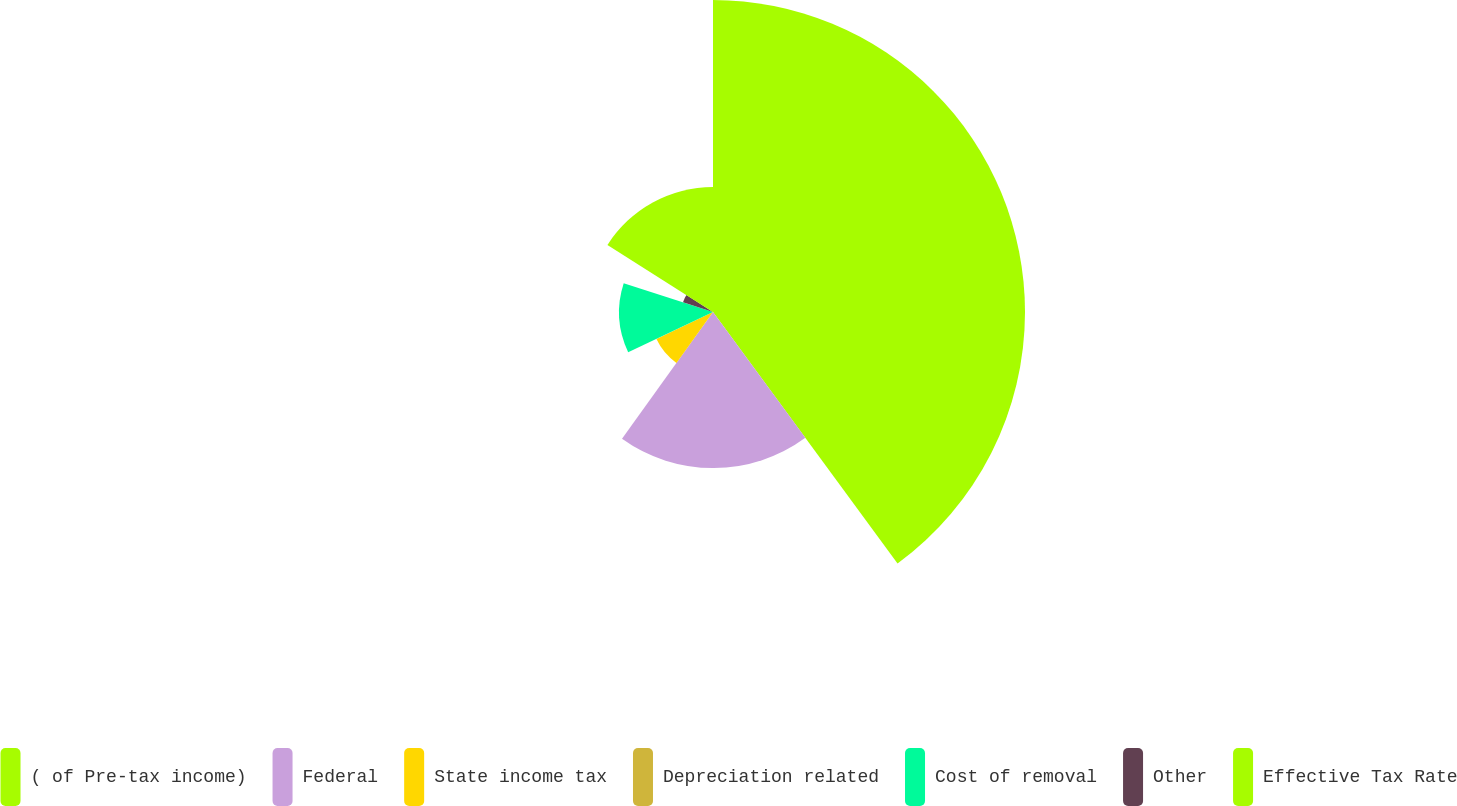Convert chart. <chart><loc_0><loc_0><loc_500><loc_500><pie_chart><fcel>( of Pre-tax income)<fcel>Federal<fcel>State income tax<fcel>Depreciation related<fcel>Cost of removal<fcel>Other<fcel>Effective Tax Rate<nl><fcel>39.93%<fcel>19.98%<fcel>8.02%<fcel>0.04%<fcel>12.01%<fcel>4.03%<fcel>16.0%<nl></chart> 